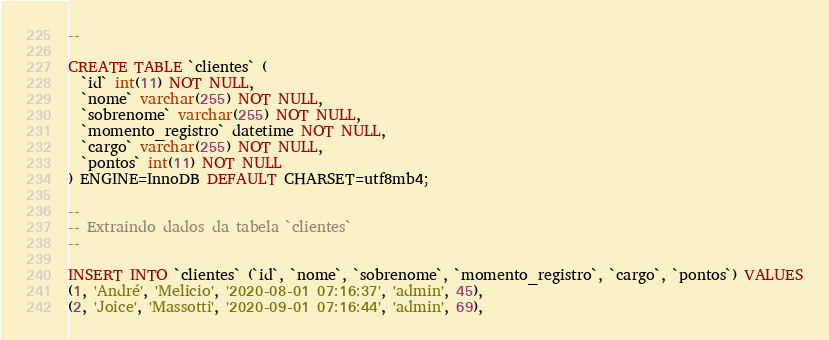Convert code to text. <code><loc_0><loc_0><loc_500><loc_500><_SQL_>--

CREATE TABLE `clientes` (
  `id` int(11) NOT NULL,
  `nome` varchar(255) NOT NULL,
  `sobrenome` varchar(255) NOT NULL,
  `momento_registro` datetime NOT NULL,
  `cargo` varchar(255) NOT NULL,
  `pontos` int(11) NOT NULL
) ENGINE=InnoDB DEFAULT CHARSET=utf8mb4;

--
-- Extraindo dados da tabela `clientes`
--

INSERT INTO `clientes` (`id`, `nome`, `sobrenome`, `momento_registro`, `cargo`, `pontos`) VALUES
(1, 'André', 'Melicio', '2020-08-01 07:16:37', 'admin', 45),
(2, 'Joice', 'Massotti', '2020-09-01 07:16:44', 'admin', 69),</code> 